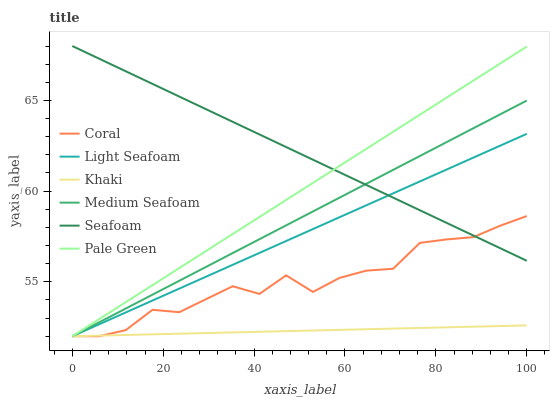Does Khaki have the minimum area under the curve?
Answer yes or no. Yes. Does Seafoam have the maximum area under the curve?
Answer yes or no. Yes. Does Coral have the minimum area under the curve?
Answer yes or no. No. Does Coral have the maximum area under the curve?
Answer yes or no. No. Is Pale Green the smoothest?
Answer yes or no. Yes. Is Coral the roughest?
Answer yes or no. Yes. Is Seafoam the smoothest?
Answer yes or no. No. Is Seafoam the roughest?
Answer yes or no. No. Does Khaki have the lowest value?
Answer yes or no. Yes. Does Seafoam have the lowest value?
Answer yes or no. No. Does Seafoam have the highest value?
Answer yes or no. Yes. Does Coral have the highest value?
Answer yes or no. No. Is Khaki less than Seafoam?
Answer yes or no. Yes. Is Seafoam greater than Khaki?
Answer yes or no. Yes. Does Pale Green intersect Light Seafoam?
Answer yes or no. Yes. Is Pale Green less than Light Seafoam?
Answer yes or no. No. Is Pale Green greater than Light Seafoam?
Answer yes or no. No. Does Khaki intersect Seafoam?
Answer yes or no. No. 